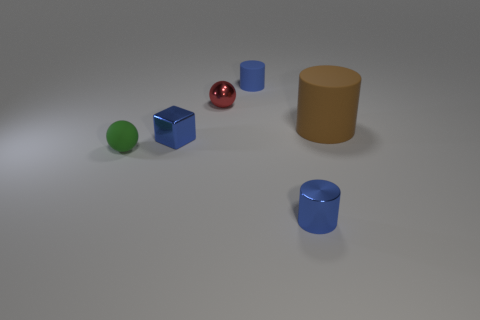Do the brown rubber object and the small green thing have the same shape?
Offer a very short reply. No. The shiny object that is the same color as the cube is what size?
Keep it short and to the point. Small. How many tiny red metallic spheres are behind the metal object that is behind the brown rubber cylinder?
Your answer should be compact. 0. What number of shiny things are in front of the brown matte cylinder and behind the green object?
Your answer should be compact. 1. How many things are tiny red spheres or cylinders on the right side of the green object?
Your answer should be compact. 4. There is a cube that is made of the same material as the red thing; what is its size?
Give a very brief answer. Small. What shape is the blue object behind the shiny object behind the big brown matte cylinder?
Your answer should be very brief. Cylinder. What number of purple things are either tiny shiny objects or small matte balls?
Your answer should be very brief. 0. There is a tiny matte thing right of the tiny ball that is on the left side of the blue shiny block; is there a tiny blue rubber object in front of it?
Give a very brief answer. No. There is a small rubber thing that is the same color as the metal cylinder; what is its shape?
Provide a short and direct response. Cylinder. 